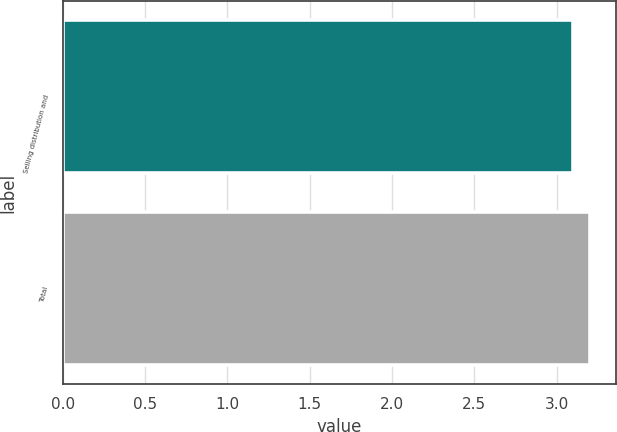Convert chart. <chart><loc_0><loc_0><loc_500><loc_500><bar_chart><fcel>Selling distribution and<fcel>Total<nl><fcel>3.1<fcel>3.2<nl></chart> 